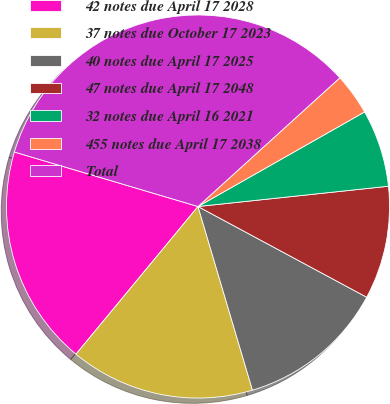<chart> <loc_0><loc_0><loc_500><loc_500><pie_chart><fcel>42 notes due April 17 2028<fcel>37 notes due October 17 2023<fcel>40 notes due April 17 2025<fcel>47 notes due April 17 2048<fcel>32 notes due April 16 2021<fcel>455 notes due April 17 2038<fcel>Total<nl><fcel>18.6%<fcel>15.58%<fcel>12.56%<fcel>9.54%<fcel>6.53%<fcel>3.51%<fcel>33.68%<nl></chart> 